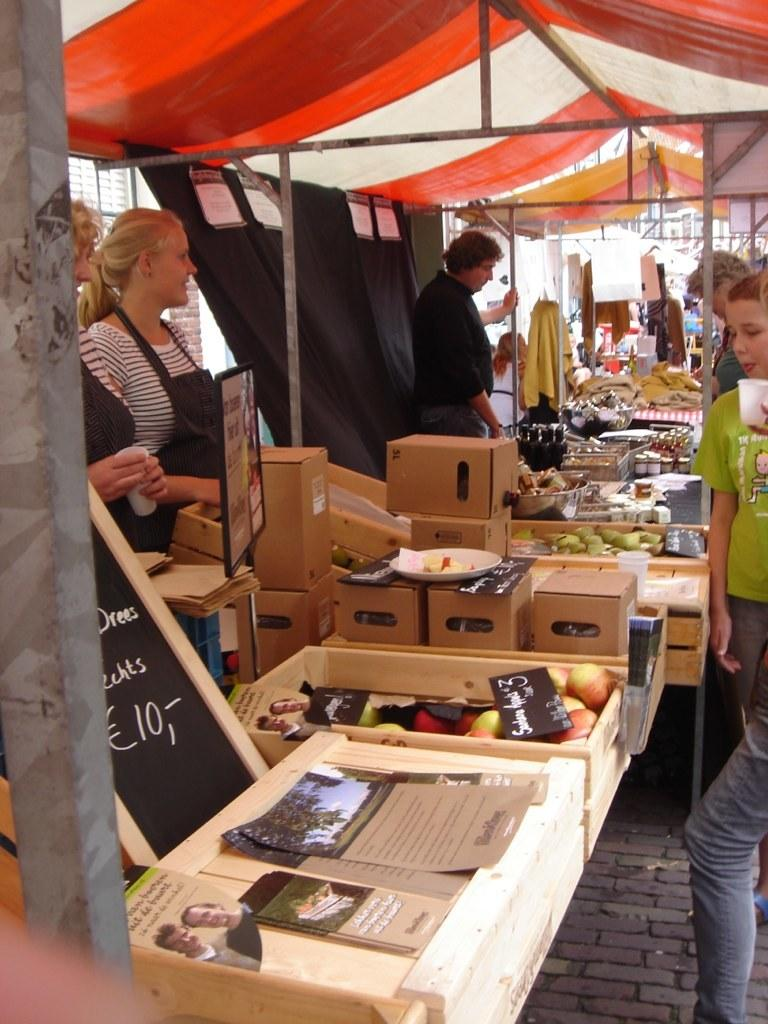What type of structures are present in the image? There are stalls with posters in the image. What can be seen on the stalls? Food items are visible on the stalls. What else is present near the stalls? There are objects present near the stalls. Who is near the stalls? People are near the stalls. What is the color of the curtain with posters in the image? There is a black color curtain with posters in the image. How does the duck travel on its journey in the image? There is no duck present in the image, so it cannot be determined how a duck would travel. 